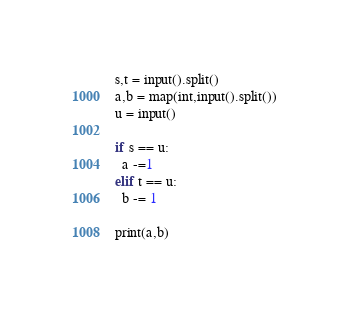<code> <loc_0><loc_0><loc_500><loc_500><_Python_>s,t = input().split()
a,b = map(int,input().split())
u = input()

if s == u:
  a -=1
elif t == u:
  b -= 1
  
print(a,b)</code> 